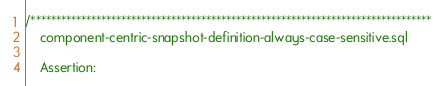<code> <loc_0><loc_0><loc_500><loc_500><_SQL_>/******************************************************************************** 
	component-centric-snapshot-definition-always-case-sensitive.sql

	Assertion:</code> 